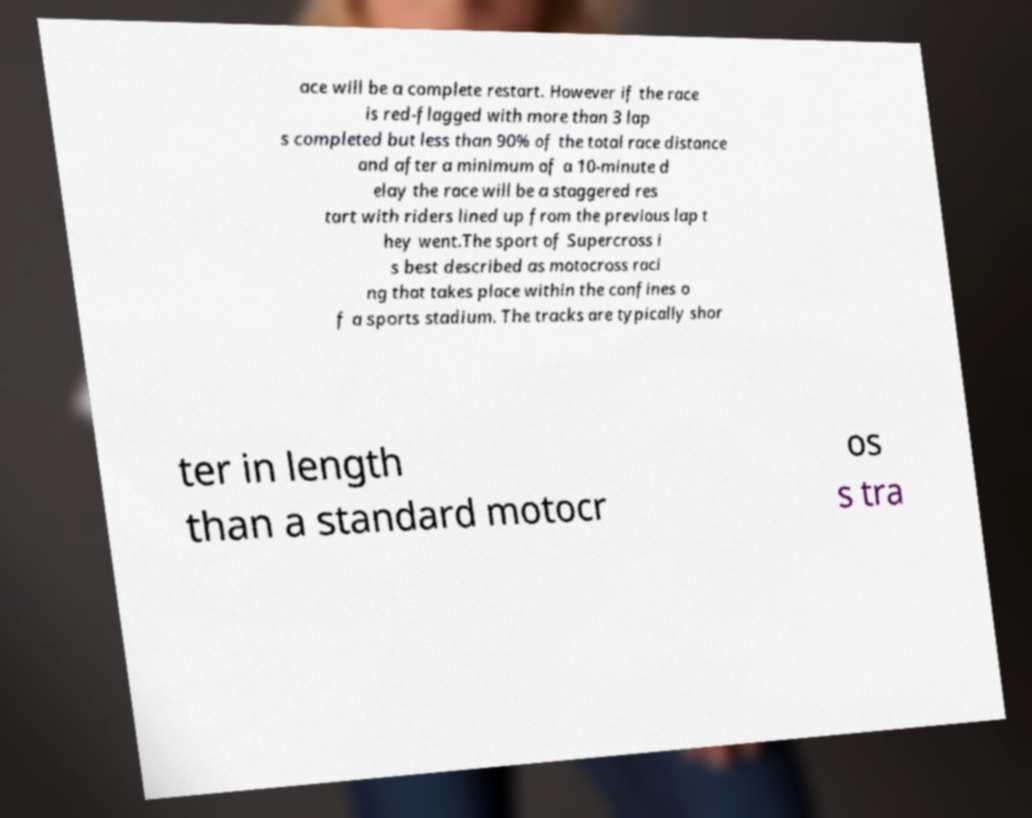I need the written content from this picture converted into text. Can you do that? ace will be a complete restart. However if the race is red-flagged with more than 3 lap s completed but less than 90% of the total race distance and after a minimum of a 10-minute d elay the race will be a staggered res tart with riders lined up from the previous lap t hey went.The sport of Supercross i s best described as motocross raci ng that takes place within the confines o f a sports stadium. The tracks are typically shor ter in length than a standard motocr os s tra 